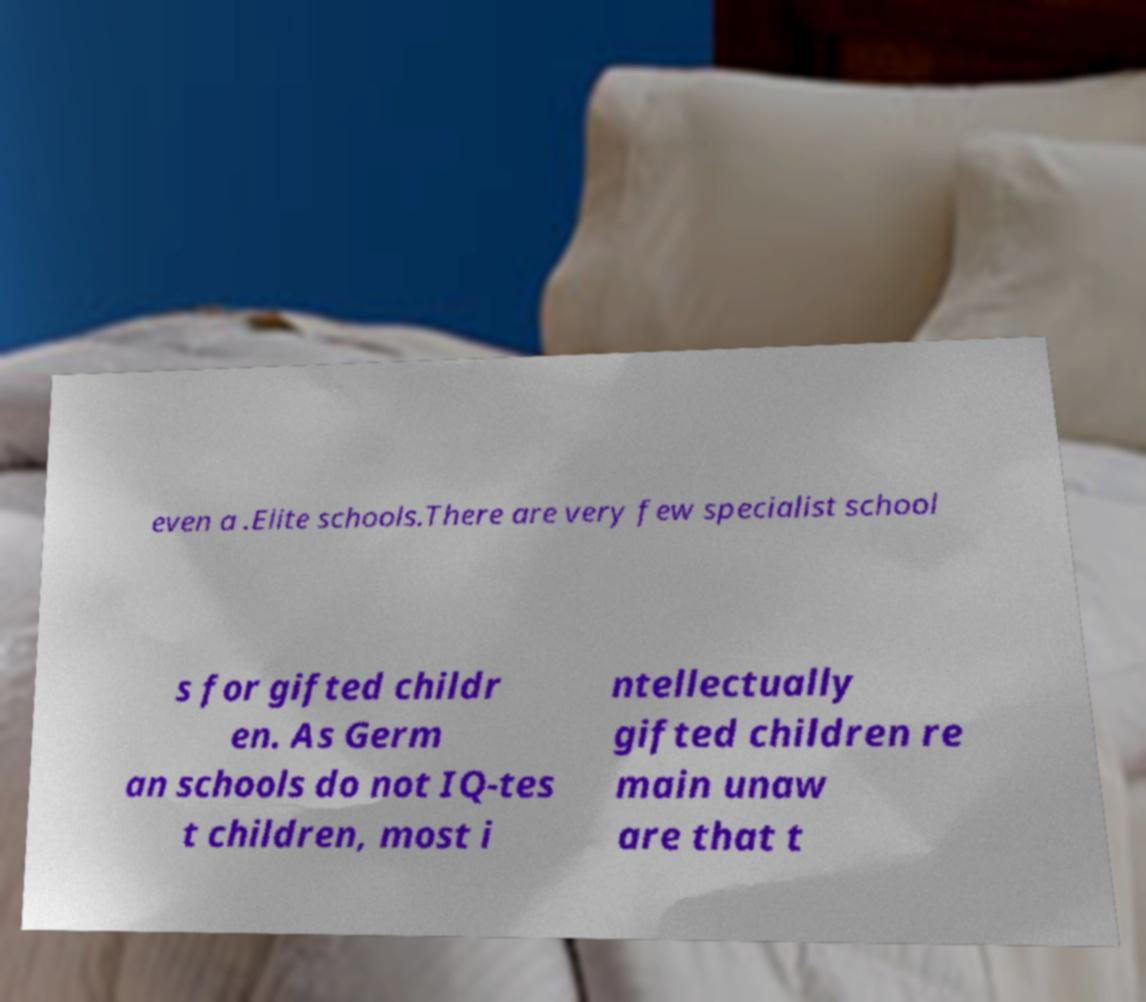Please identify and transcribe the text found in this image. even a .Elite schools.There are very few specialist school s for gifted childr en. As Germ an schools do not IQ-tes t children, most i ntellectually gifted children re main unaw are that t 